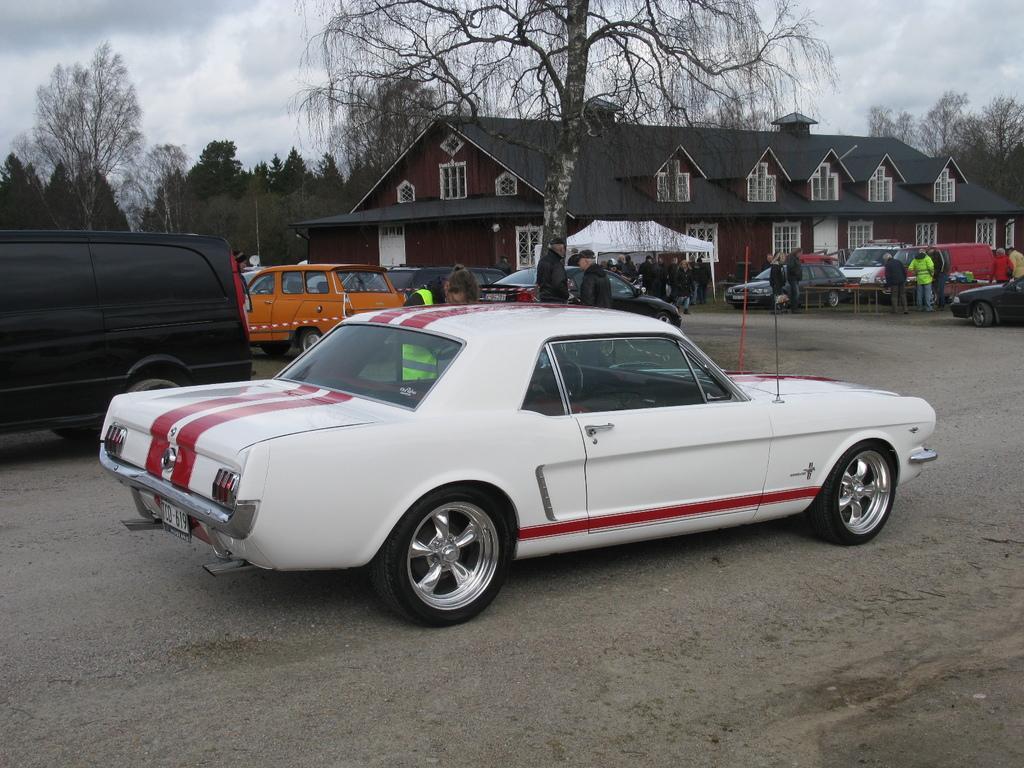How would you summarize this image in a sentence or two? This is the picture of a place where we have a house and around there are some trees, plants, cars and some other people. 